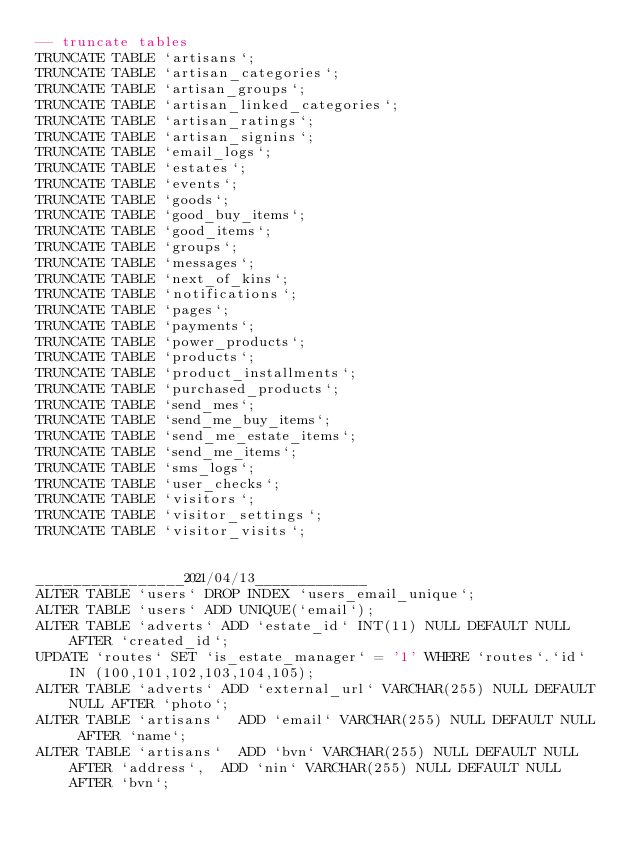<code> <loc_0><loc_0><loc_500><loc_500><_SQL_>-- truncate tables
TRUNCATE TABLE `artisans`;
TRUNCATE TABLE `artisan_categories`;
TRUNCATE TABLE `artisan_groups`;
TRUNCATE TABLE `artisan_linked_categories`;
TRUNCATE TABLE `artisan_ratings`;
TRUNCATE TABLE `artisan_signins`;
TRUNCATE TABLE `email_logs`;
TRUNCATE TABLE `estates`;
TRUNCATE TABLE `events`;
TRUNCATE TABLE `goods`;
TRUNCATE TABLE `good_buy_items`;
TRUNCATE TABLE `good_items`;
TRUNCATE TABLE `groups`;
TRUNCATE TABLE `messages`;
TRUNCATE TABLE `next_of_kins`;
TRUNCATE TABLE `notifications`;
TRUNCATE TABLE `pages`;
TRUNCATE TABLE `payments`;
TRUNCATE TABLE `power_products`;
TRUNCATE TABLE `products`;
TRUNCATE TABLE `product_installments`;
TRUNCATE TABLE `purchased_products`;
TRUNCATE TABLE `send_mes`;
TRUNCATE TABLE `send_me_buy_items`;
TRUNCATE TABLE `send_me_estate_items`;
TRUNCATE TABLE `send_me_items`;
TRUNCATE TABLE `sms_logs`;
TRUNCATE TABLE `user_checks`;
TRUNCATE TABLE `visitors`;
TRUNCATE TABLE `visitor_settings`;
TRUNCATE TABLE `visitor_visits`;


________________2021/04/13_____________
ALTER TABLE `users` DROP INDEX `users_email_unique`;
ALTER TABLE `users` ADD UNIQUE(`email`);
ALTER TABLE `adverts` ADD `estate_id` INT(11) NULL DEFAULT NULL AFTER `created_id`;
UPDATE `routes` SET `is_estate_manager` = '1' WHERE `routes`.`id` IN (100,101,102,103,104,105);
ALTER TABLE `adverts` ADD `external_url` VARCHAR(255) NULL DEFAULT NULL AFTER `photo`;
ALTER TABLE `artisans`  ADD `email` VARCHAR(255) NULL DEFAULT NULL  AFTER `name`;
ALTER TABLE `artisans`  ADD `bvn` VARCHAR(255) NULL DEFAULT NULL  AFTER `address`,  ADD `nin` VARCHAR(255) NULL DEFAULT NULL  AFTER `bvn`;</code> 